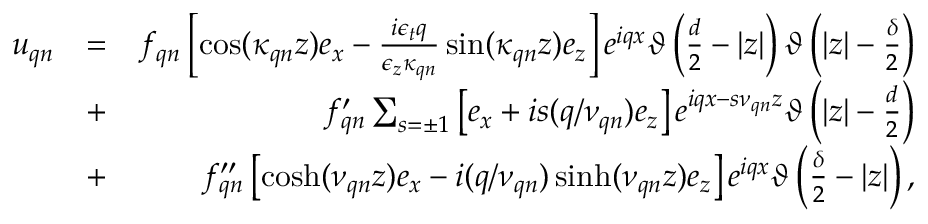Convert formula to latex. <formula><loc_0><loc_0><loc_500><loc_500>\begin{array} { r l r } { u _ { q n } } & { = } & { f _ { q n } \left [ \cos ( \kappa _ { q n } z ) e _ { x } - \frac { i \epsilon _ { t } q } { \epsilon _ { z } \kappa _ { q n } } \sin ( \kappa _ { q n } z ) e _ { z } \right ] e ^ { i q x } \vartheta \left ( \frac { d } { 2 } - | z | \right ) \vartheta \left ( | z | - \frac { \delta } { 2 } \right ) } \\ & { + } & { f _ { q n } ^ { \prime } \sum _ { s = \pm 1 } \left [ e _ { x } + i s ( q / \nu _ { q n } ) e _ { z } \right ] e ^ { i q x - s \nu _ { q n } z } \vartheta \left ( | z | - \frac { d } { 2 } \right ) } \\ & { + } & { f _ { q n } ^ { \prime \prime } \left [ \cosh ( \nu _ { q n } z ) e _ { x } - i ( q / \nu _ { q n } ) \sinh ( \nu _ { q n } z ) e _ { z } \right ] e ^ { i q x } \vartheta \left ( \frac { \delta } { 2 } - | z | \right ) , } \end{array}</formula> 